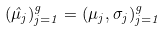Convert formula to latex. <formula><loc_0><loc_0><loc_500><loc_500>( \hat { \mu } _ { j } ) _ { j = 1 } ^ { g } = ( \mu _ { j } , \sigma _ { j } ) _ { j = 1 } ^ { g }</formula> 